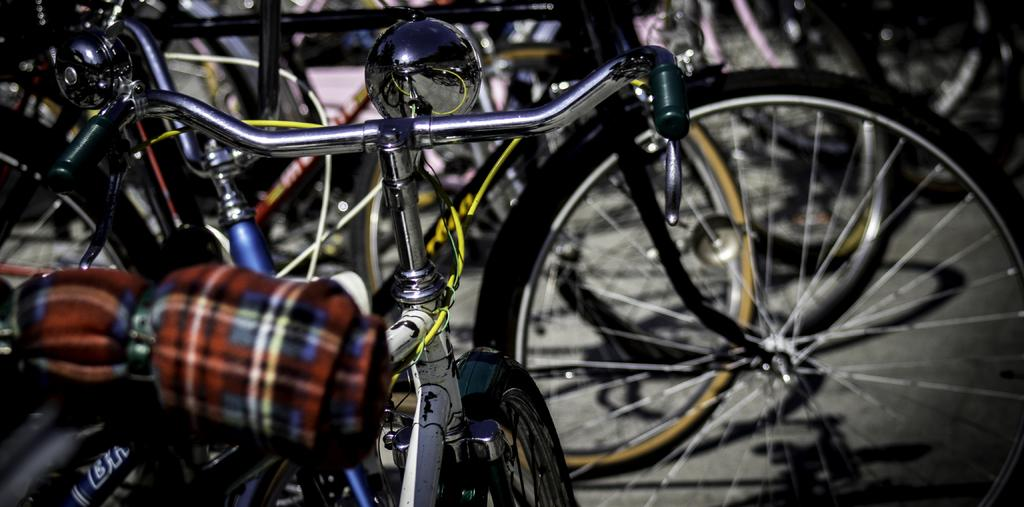What type of vehicles are present in the image? There are bicycles in the image. Can you describe the appearance of one of the bicycles? There is a bicycle on the left side with a colorful object on it. What type of quiet writer can be seen riding the bicycle on the right side of the image? There is no writer or donkey present in the image; it only features bicycles. 